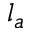<formula> <loc_0><loc_0><loc_500><loc_500>l _ { a }</formula> 